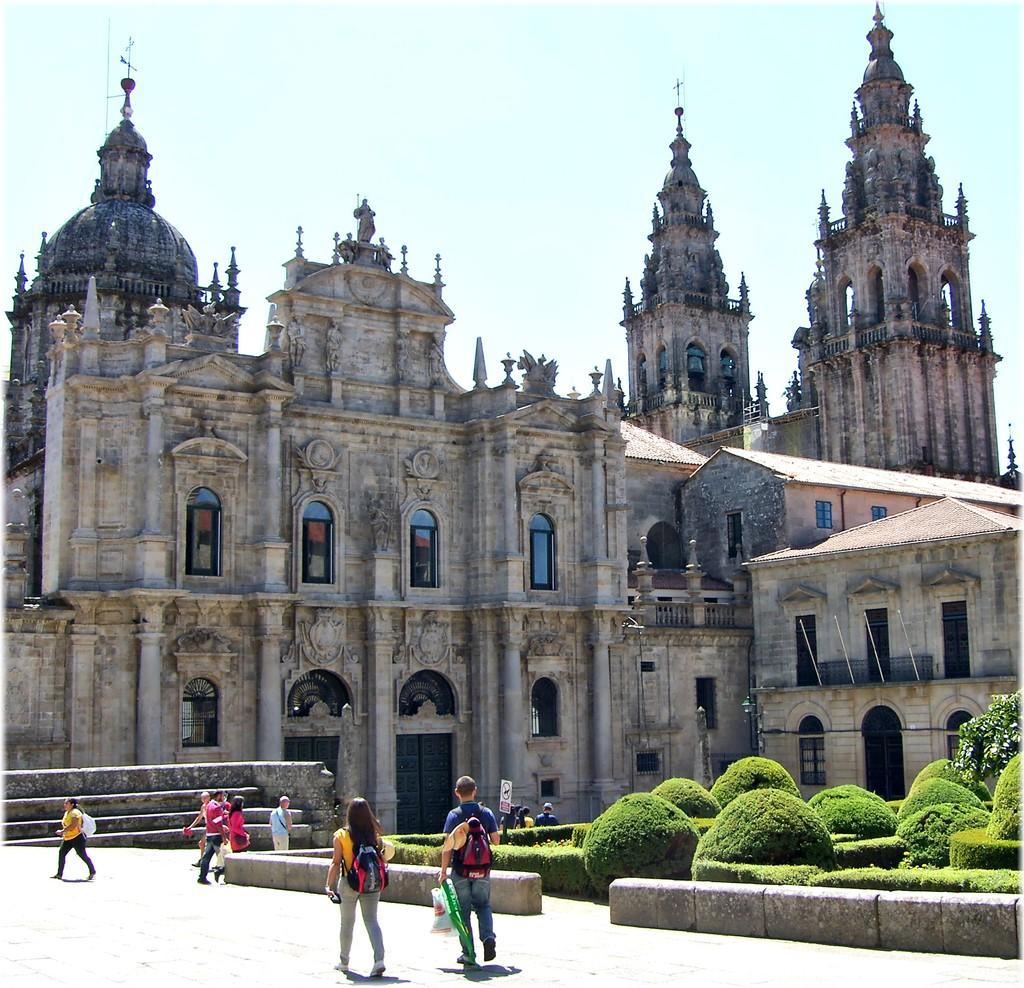What is the main structure visible in the image? There is a monument in the image. What is located in front of the monument? There is a park in front of the monument. How is the park described? The park is described as beautiful. What can be observed about the people in the park? There are people moving on the path around the park. What type of nerve can be seen in the image? There is no nerve visible in the image; it features a monument and a park. How many leaves are present on the monument in the image? There are no leaves present on the monument in the image. 